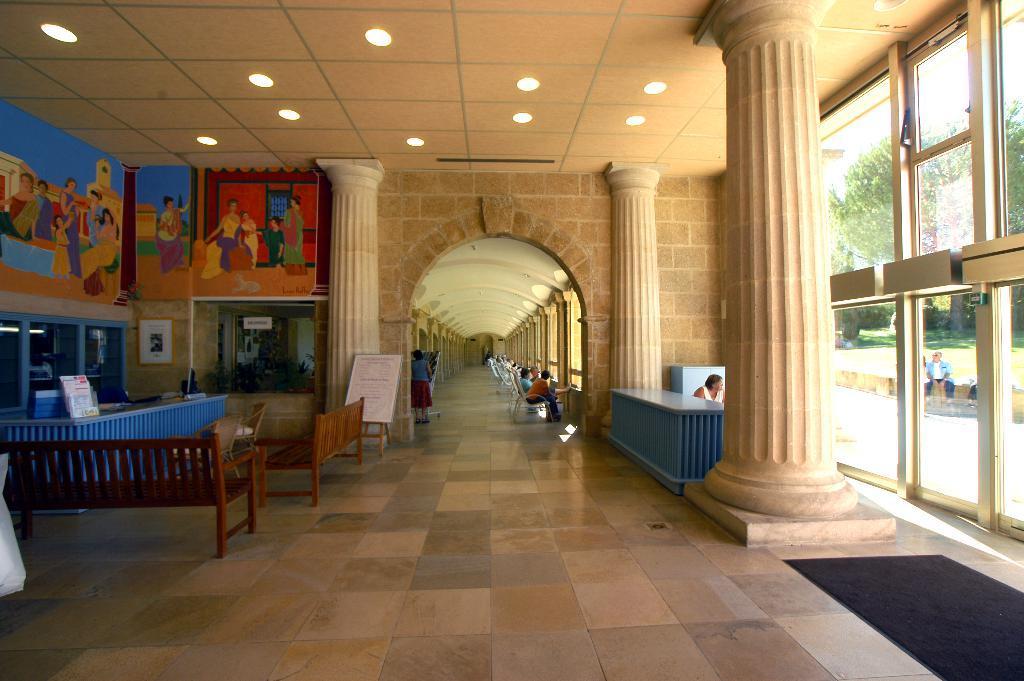Could you give a brief overview of what you see in this image? In this image I can see inside view of a building. On the left side I can see few benches, few chairs, a white colour board and a white colour frame on the wall. I can also see paintings on these walls. On the right side of this image I can see few people, a glass door and few trees. In the background I can see number of people where one is standing and rest all are sitting on chairs. On the top side of this image I can see number of lights on the ceiling. I can also see three pillars in the centre of this image. 